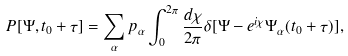Convert formula to latex. <formula><loc_0><loc_0><loc_500><loc_500>P [ \Psi , t _ { 0 } + \tau ] = \sum _ { \alpha } p _ { \alpha } \int _ { 0 } ^ { 2 \pi } \frac { d \chi } { 2 \pi } \delta [ \Psi - e ^ { i \chi } \Psi _ { \alpha } ( t _ { 0 } + \tau ) ] ,</formula> 